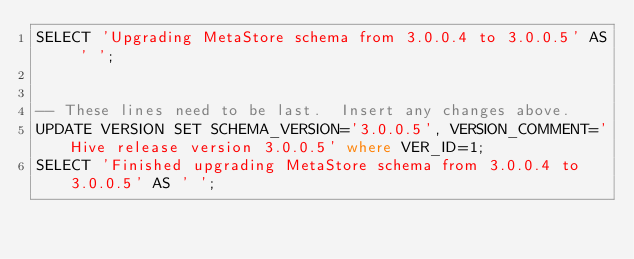Convert code to text. <code><loc_0><loc_0><loc_500><loc_500><_SQL_>SELECT 'Upgrading MetaStore schema from 3.0.0.4 to 3.0.0.5' AS ' ';


-- These lines need to be last.  Insert any changes above.
UPDATE VERSION SET SCHEMA_VERSION='3.0.0.5', VERSION_COMMENT='Hive release version 3.0.0.5' where VER_ID=1;
SELECT 'Finished upgrading MetaStore schema from 3.0.0.4 to 3.0.0.5' AS ' ';
</code> 